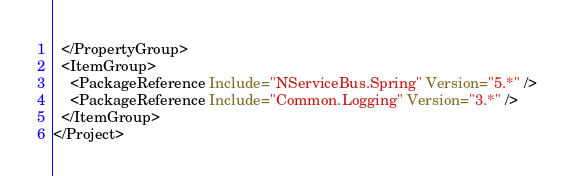<code> <loc_0><loc_0><loc_500><loc_500><_XML_>  </PropertyGroup>
  <ItemGroup>
    <PackageReference Include="NServiceBus.Spring" Version="5.*" />
    <PackageReference Include="Common.Logging" Version="3.*" />
  </ItemGroup>
</Project></code> 